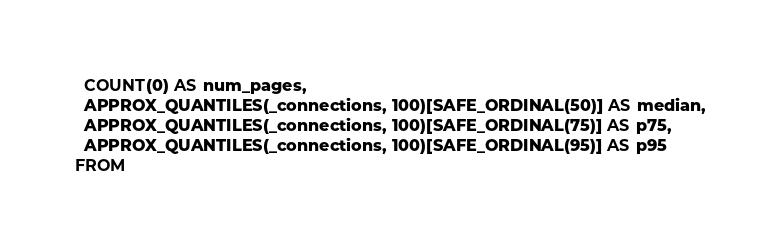Convert code to text. <code><loc_0><loc_0><loc_500><loc_500><_SQL_>  COUNT(0) AS num_pages,
  APPROX_QUANTILES(_connections, 100)[SAFE_ORDINAL(50)] AS median,
  APPROX_QUANTILES(_connections, 100)[SAFE_ORDINAL(75)] AS p75,
  APPROX_QUANTILES(_connections, 100)[SAFE_ORDINAL(95)] AS p95
FROM </code> 